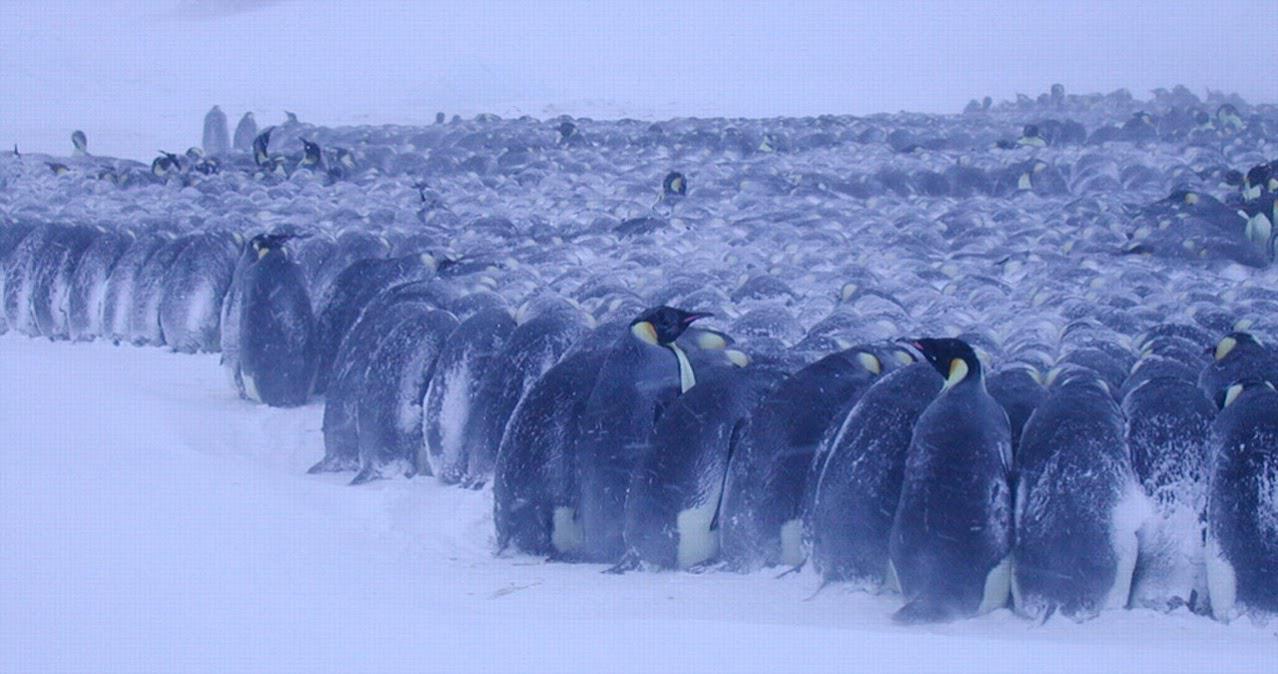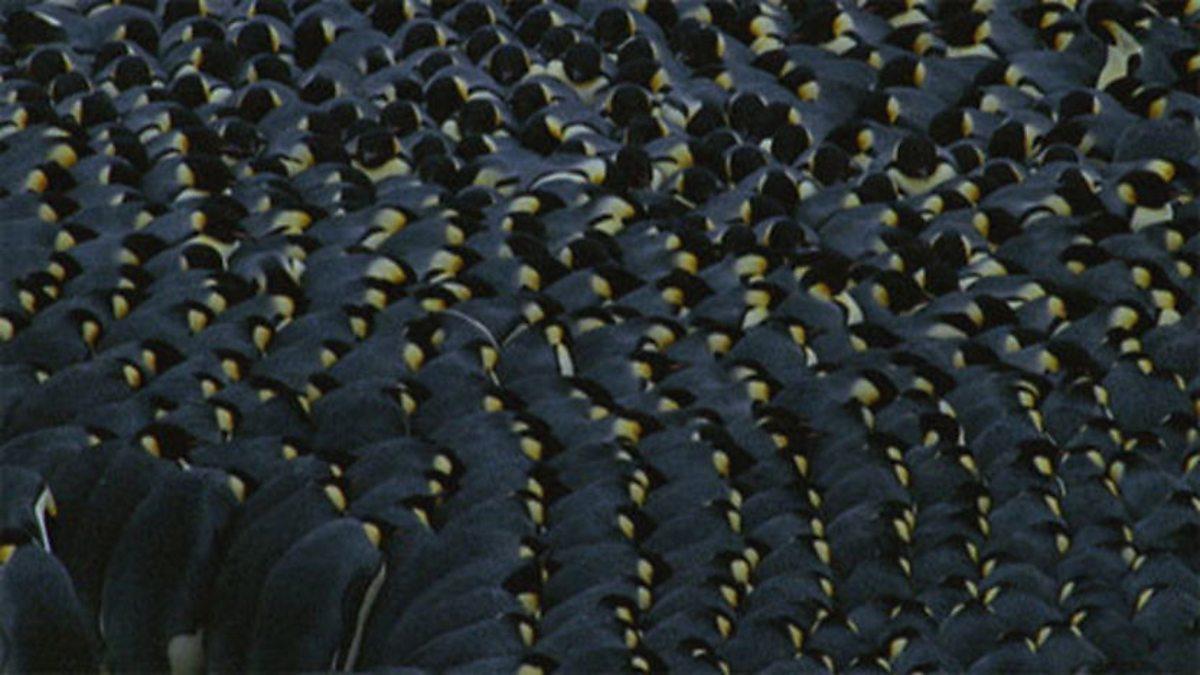The first image is the image on the left, the second image is the image on the right. Assess this claim about the two images: "In one image the penguins are all huddled together and there is snow on the backs of the outermost penguins.". Correct or not? Answer yes or no. Yes. 